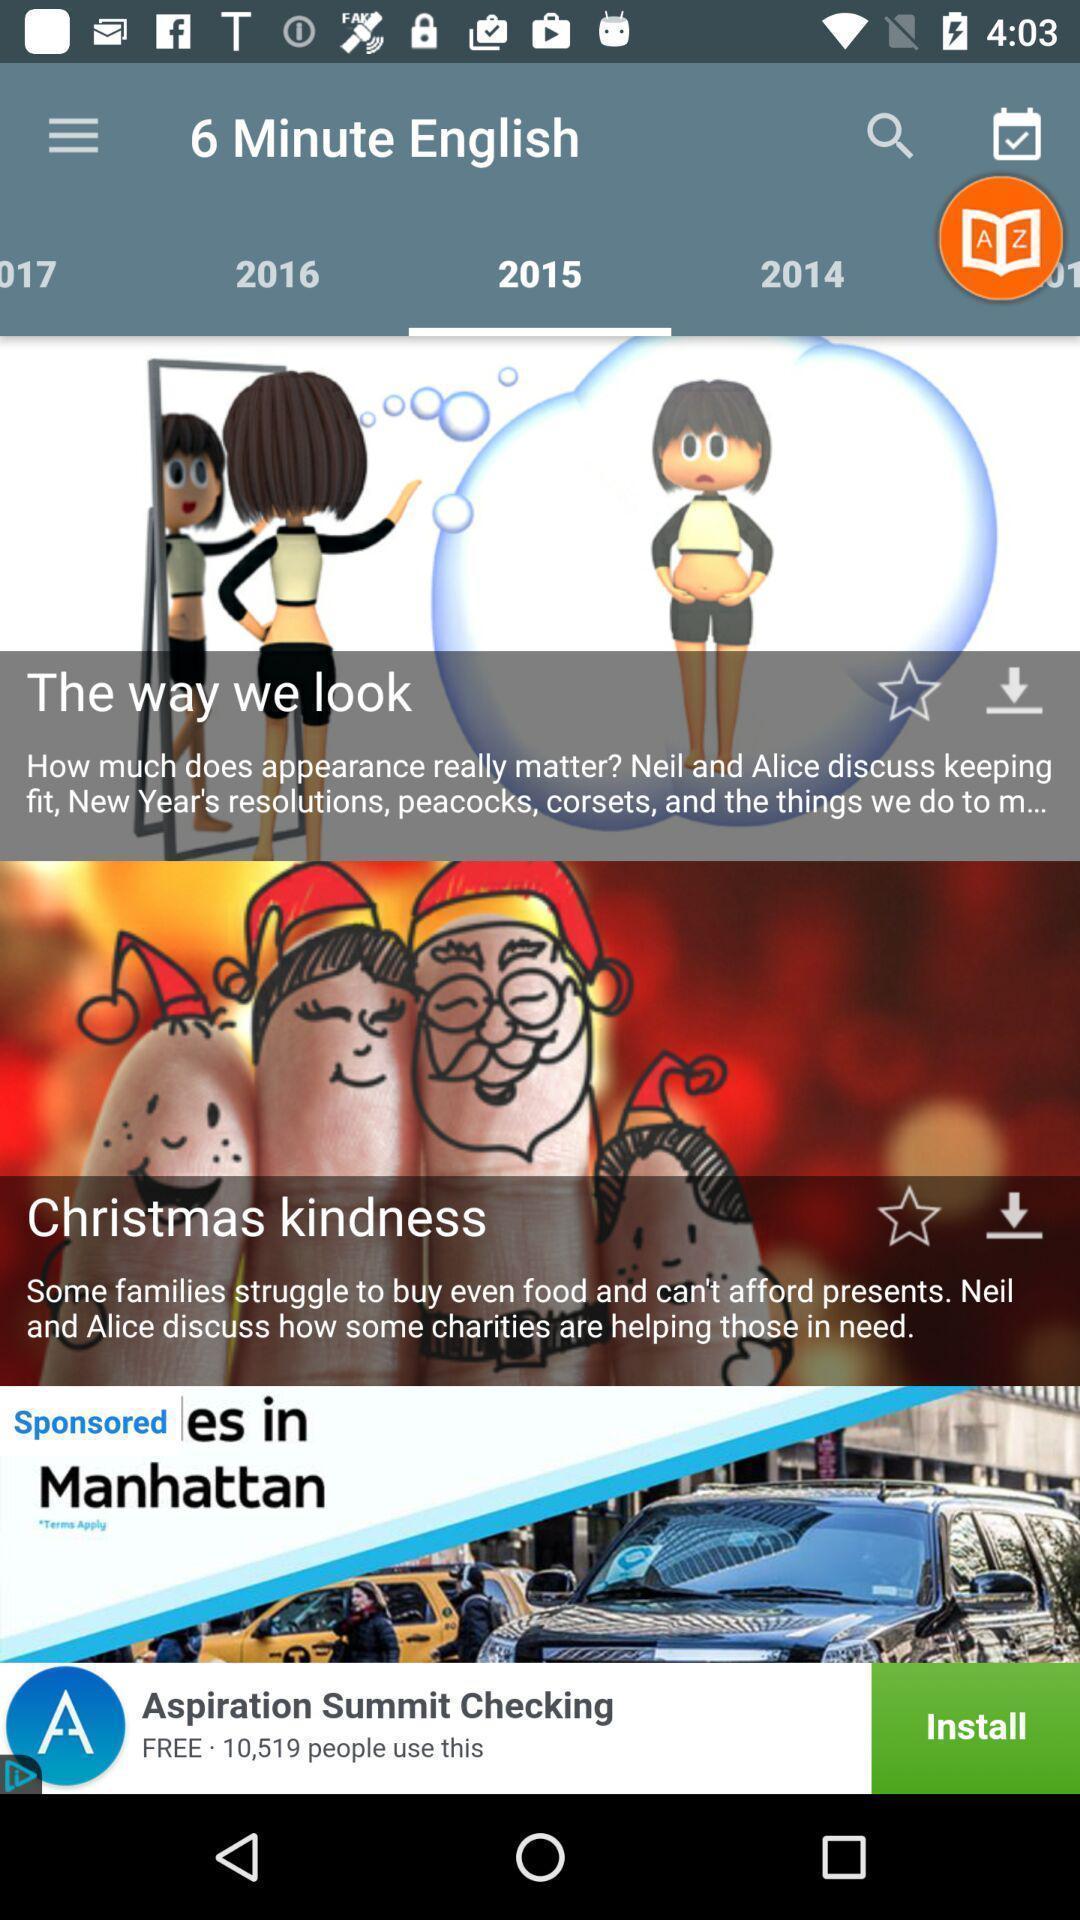Give me a summary of this screen capture. Videos with years in study app. 